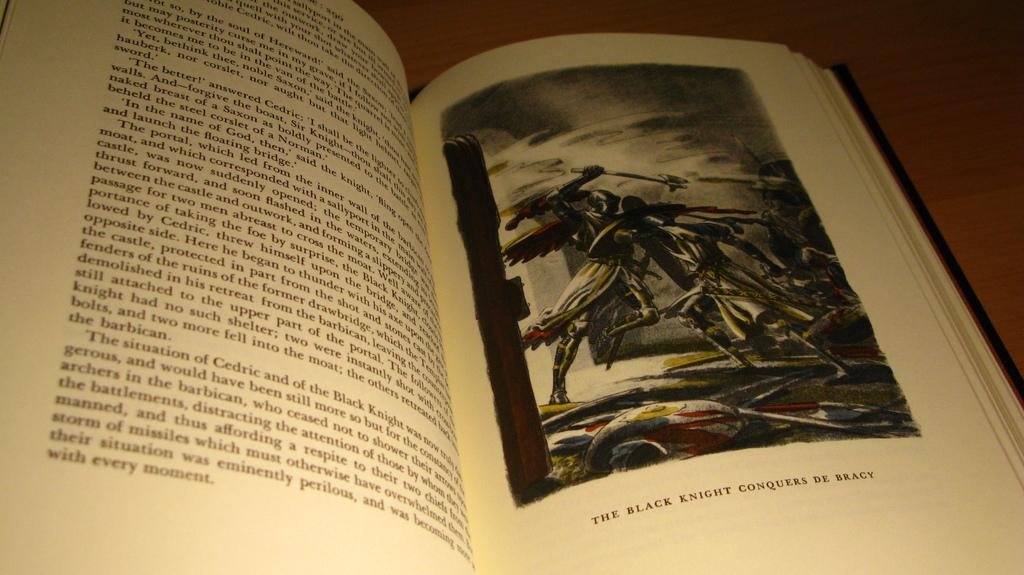Provide a one-sentence caption for the provided image. A book sits open to a page with a picture of The black night conquers De Bracy. 